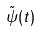<formula> <loc_0><loc_0><loc_500><loc_500>\tilde { \psi } ( t )</formula> 